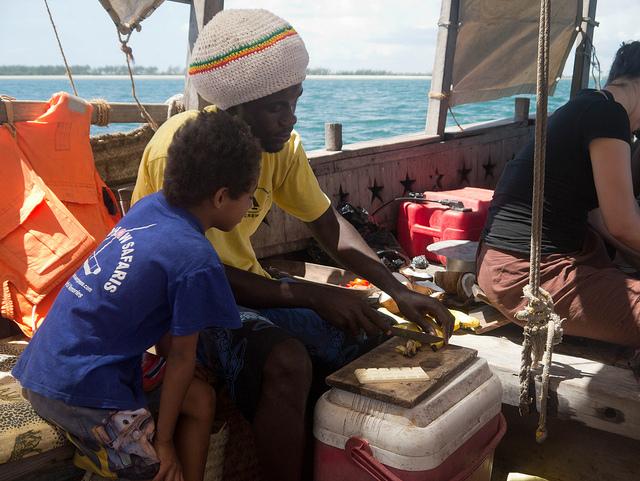Are the men cooking or playing chess?
Give a very brief answer. Cooking. Is there a boy with blue shirt?
Concise answer only. Yes. What is the man cutting?
Concise answer only. Food. 